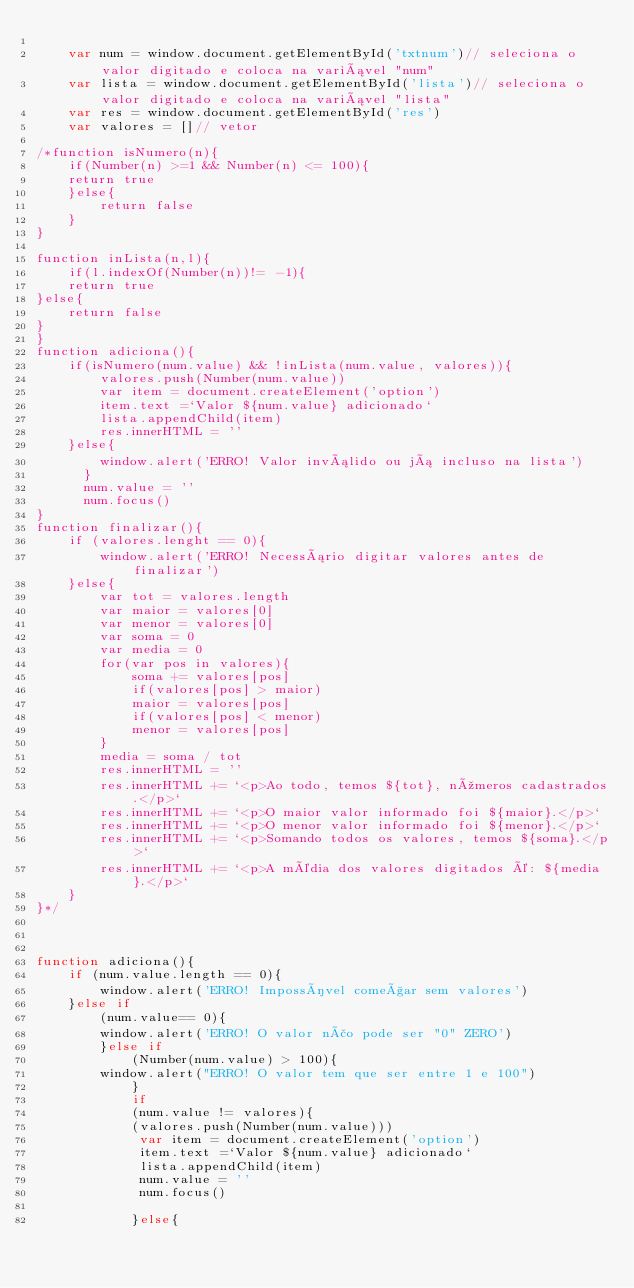Convert code to text. <code><loc_0><loc_0><loc_500><loc_500><_JavaScript_>
    var num = window.document.getElementById('txtnum')// seleciona o valor digitado e coloca na variável "num"
    var lista = window.document.getElementById('lista')// seleciona o valor digitado e coloca na variável "lista"
    var res = window.document.getElementById('res') 
    var valores = []// vetor

/*function isNumero(n){
    if(Number(n) >=1 && Number(n) <= 100){
    return true
    }else{
        return false
    }
}

function inLista(n,l){
    if(l.indexOf(Number(n))!= -1){
    return true
}else{
    return false
}
}
function adiciona(){
    if(isNumero(num.value) && !inLista(num.value, valores)){
        valores.push(Number(num.value))
        var item = document.createElement('option')
        item.text =`Valor ${num.value} adicionado`
        lista.appendChild(item)
        res.innerHTML = ''
    }else{
        window.alert('ERRO! Valor inválido ou já incluso na lista')
      }
      num.value = ''
      num.focus()
}
function finalizar(){
    if (valores.lenght == 0){
        window.alert('ERRO! Necessário digitar valores antes de finalizar')
    }else{
        var tot = valores.length
        var maior = valores[0]
        var menor = valores[0]
        var soma = 0
        var media = 0
        for(var pos in valores){
            soma += valores[pos]
            if(valores[pos] > maior)
            maior = valores[pos]
            if(valores[pos] < menor)
            menor = valores[pos]
        }
        media = soma / tot
        res.innerHTML = ''
        res.innerHTML += `<p>Ao todo, temos ${tot}, números cadastrados.</p>`
        res.innerHTML += `<p>O maior valor informado foi ${maior}.</p>`
        res.innerHTML += `<p>O menor valor informado foi ${menor}.</p>`
        res.innerHTML += `<p>Somando todos os valores, temos ${soma}.</p>`
        res.innerHTML += `<p>A média dos valores digitados é: ${media}.</p>`
    }
}*/



function adiciona(){
    if (num.value.length == 0){
        window.alert('ERRO! Impossível começar sem valores')
    }else if
        (num.value== 0){
        window.alert('ERRO! O valor não pode ser "0" ZERO')
        }else if
            (Number(num.value) > 100){
        window.alert("ERRO! O valor tem que ser entre 1 e 100")   
            }
            if
            (num.value != valores){
            (valores.push(Number(num.value)))
             var item = document.createElement('option')
             item.text =`Valor ${num.value} adicionado`
             lista.appendChild(item)
             num.value = ''
             num.focus()

            }else{</code> 